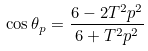Convert formula to latex. <formula><loc_0><loc_0><loc_500><loc_500>\, \cos \theta _ { p } = \frac { 6 - 2 T ^ { 2 } p ^ { 2 } } { 6 + T ^ { 2 } p ^ { 2 } }</formula> 